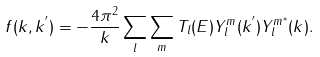Convert formula to latex. <formula><loc_0><loc_0><loc_500><loc_500>f ( { k } , { k ^ { ^ { \prime } } } ) = - \frac { 4 \pi ^ { 2 } } { k } \sum _ { l } \sum _ { m } T _ { l } ( E ) Y ^ { m } _ { l } ( { k ^ { ^ { \prime } } } ) Y ^ { m ^ { * } } _ { l } ( k ) .</formula> 